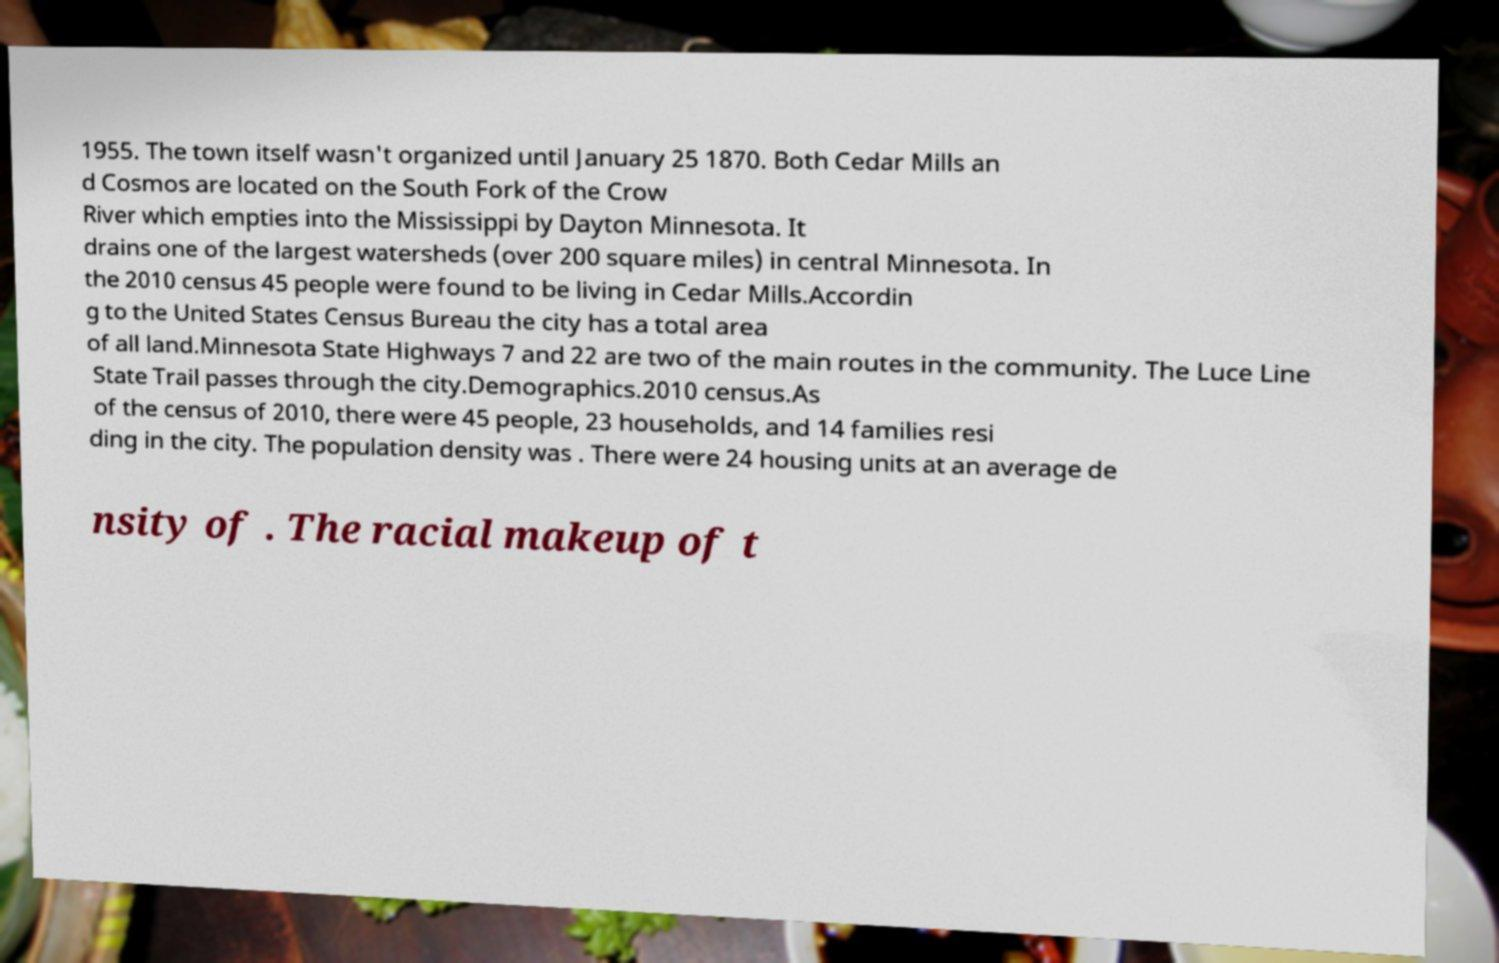Could you assist in decoding the text presented in this image and type it out clearly? 1955. The town itself wasn't organized until January 25 1870. Both Cedar Mills an d Cosmos are located on the South Fork of the Crow River which empties into the Mississippi by Dayton Minnesota. It drains one of the largest watersheds (over 200 square miles) in central Minnesota. In the 2010 census 45 people were found to be living in Cedar Mills.Accordin g to the United States Census Bureau the city has a total area of all land.Minnesota State Highways 7 and 22 are two of the main routes in the community. The Luce Line State Trail passes through the city.Demographics.2010 census.As of the census of 2010, there were 45 people, 23 households, and 14 families resi ding in the city. The population density was . There were 24 housing units at an average de nsity of . The racial makeup of t 